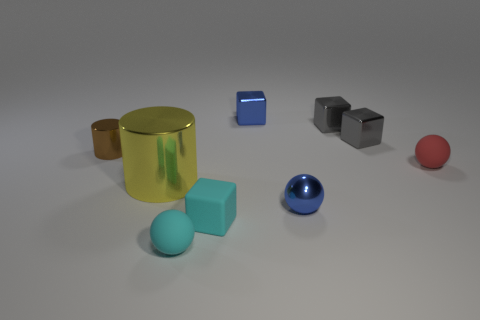Subtract all green spheres. Subtract all green blocks. How many spheres are left? 3 Add 1 small gray things. How many objects exist? 10 Subtract all spheres. How many objects are left? 6 Add 6 tiny red objects. How many tiny red objects exist? 7 Subtract 1 red spheres. How many objects are left? 8 Subtract all small red matte things. Subtract all tiny cyan rubber spheres. How many objects are left? 7 Add 7 big metallic things. How many big metallic things are left? 8 